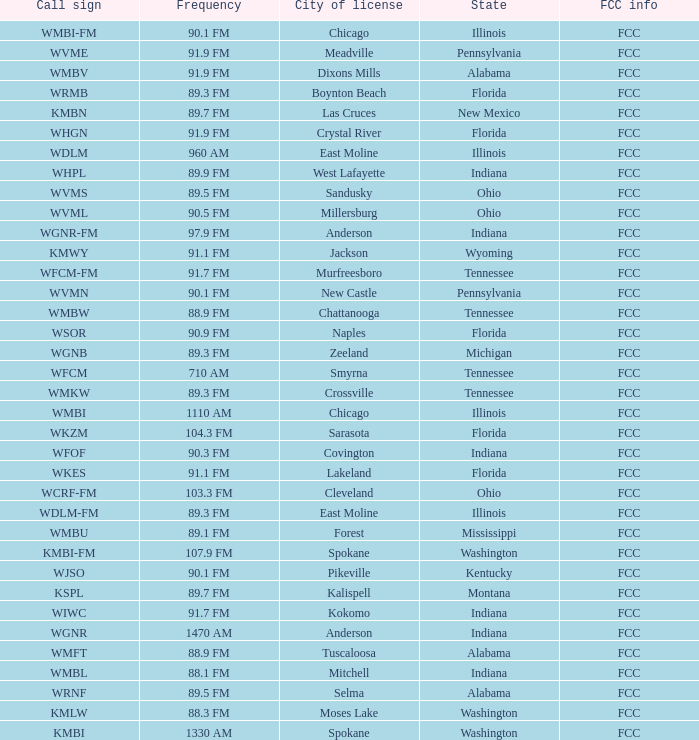What is the frequency of the radio station in Indiana that has a call sign of WGNR? 1470 AM. Could you parse the entire table as a dict? {'header': ['Call sign', 'Frequency', 'City of license', 'State', 'FCC info'], 'rows': [['WMBI-FM', '90.1 FM', 'Chicago', 'Illinois', 'FCC'], ['WVME', '91.9 FM', 'Meadville', 'Pennsylvania', 'FCC'], ['WMBV', '91.9 FM', 'Dixons Mills', 'Alabama', 'FCC'], ['WRMB', '89.3 FM', 'Boynton Beach', 'Florida', 'FCC'], ['KMBN', '89.7 FM', 'Las Cruces', 'New Mexico', 'FCC'], ['WHGN', '91.9 FM', 'Crystal River', 'Florida', 'FCC'], ['WDLM', '960 AM', 'East Moline', 'Illinois', 'FCC'], ['WHPL', '89.9 FM', 'West Lafayette', 'Indiana', 'FCC'], ['WVMS', '89.5 FM', 'Sandusky', 'Ohio', 'FCC'], ['WVML', '90.5 FM', 'Millersburg', 'Ohio', 'FCC'], ['WGNR-FM', '97.9 FM', 'Anderson', 'Indiana', 'FCC'], ['KMWY', '91.1 FM', 'Jackson', 'Wyoming', 'FCC'], ['WFCM-FM', '91.7 FM', 'Murfreesboro', 'Tennessee', 'FCC'], ['WVMN', '90.1 FM', 'New Castle', 'Pennsylvania', 'FCC'], ['WMBW', '88.9 FM', 'Chattanooga', 'Tennessee', 'FCC'], ['WSOR', '90.9 FM', 'Naples', 'Florida', 'FCC'], ['WGNB', '89.3 FM', 'Zeeland', 'Michigan', 'FCC'], ['WFCM', '710 AM', 'Smyrna', 'Tennessee', 'FCC'], ['WMKW', '89.3 FM', 'Crossville', 'Tennessee', 'FCC'], ['WMBI', '1110 AM', 'Chicago', 'Illinois', 'FCC'], ['WKZM', '104.3 FM', 'Sarasota', 'Florida', 'FCC'], ['WFOF', '90.3 FM', 'Covington', 'Indiana', 'FCC'], ['WKES', '91.1 FM', 'Lakeland', 'Florida', 'FCC'], ['WCRF-FM', '103.3 FM', 'Cleveland', 'Ohio', 'FCC'], ['WDLM-FM', '89.3 FM', 'East Moline', 'Illinois', 'FCC'], ['WMBU', '89.1 FM', 'Forest', 'Mississippi', 'FCC'], ['KMBI-FM', '107.9 FM', 'Spokane', 'Washington', 'FCC'], ['WJSO', '90.1 FM', 'Pikeville', 'Kentucky', 'FCC'], ['KSPL', '89.7 FM', 'Kalispell', 'Montana', 'FCC'], ['WIWC', '91.7 FM', 'Kokomo', 'Indiana', 'FCC'], ['WGNR', '1470 AM', 'Anderson', 'Indiana', 'FCC'], ['WMFT', '88.9 FM', 'Tuscaloosa', 'Alabama', 'FCC'], ['WMBL', '88.1 FM', 'Mitchell', 'Indiana', 'FCC'], ['WRNF', '89.5 FM', 'Selma', 'Alabama', 'FCC'], ['KMLW', '88.3 FM', 'Moses Lake', 'Washington', 'FCC'], ['KMBI', '1330 AM', 'Spokane', 'Washington', 'FCC']]} 